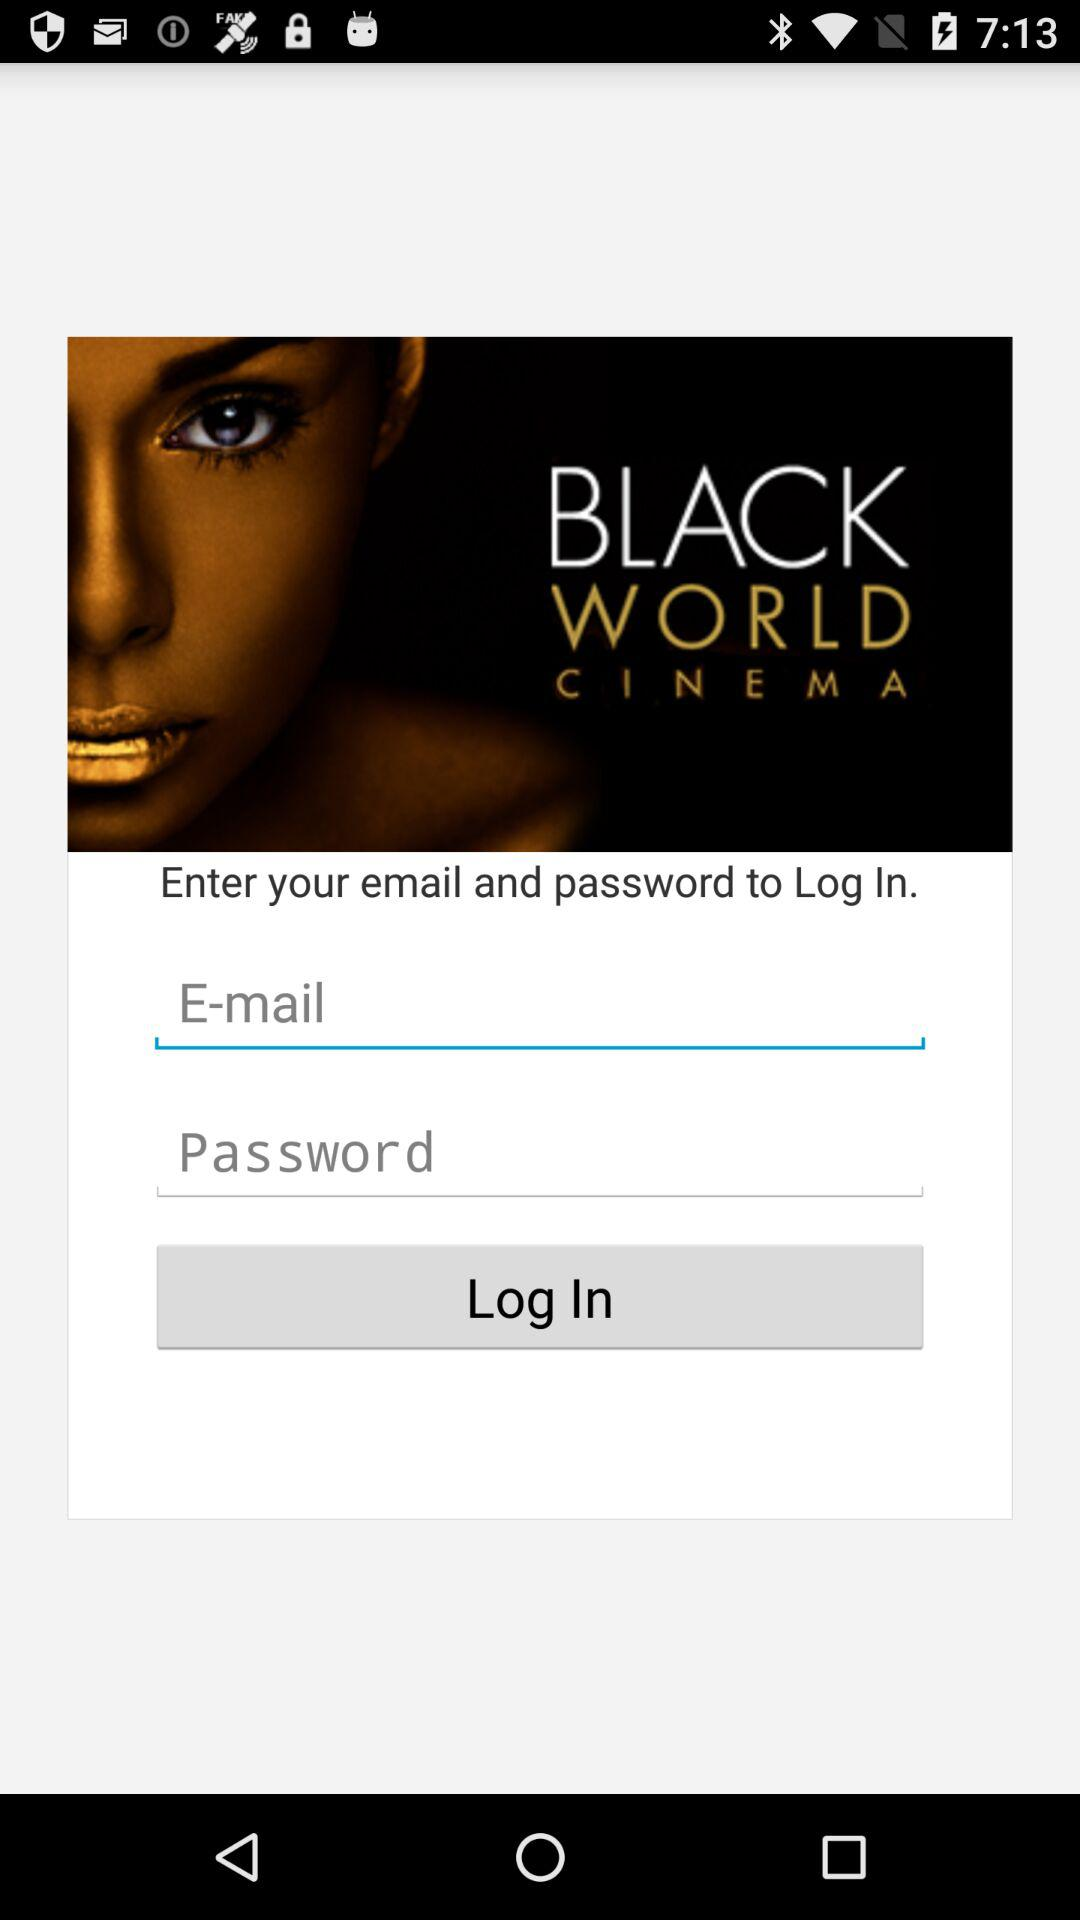How many characters are required for the password?
When the provided information is insufficient, respond with <no answer>. <no answer> 